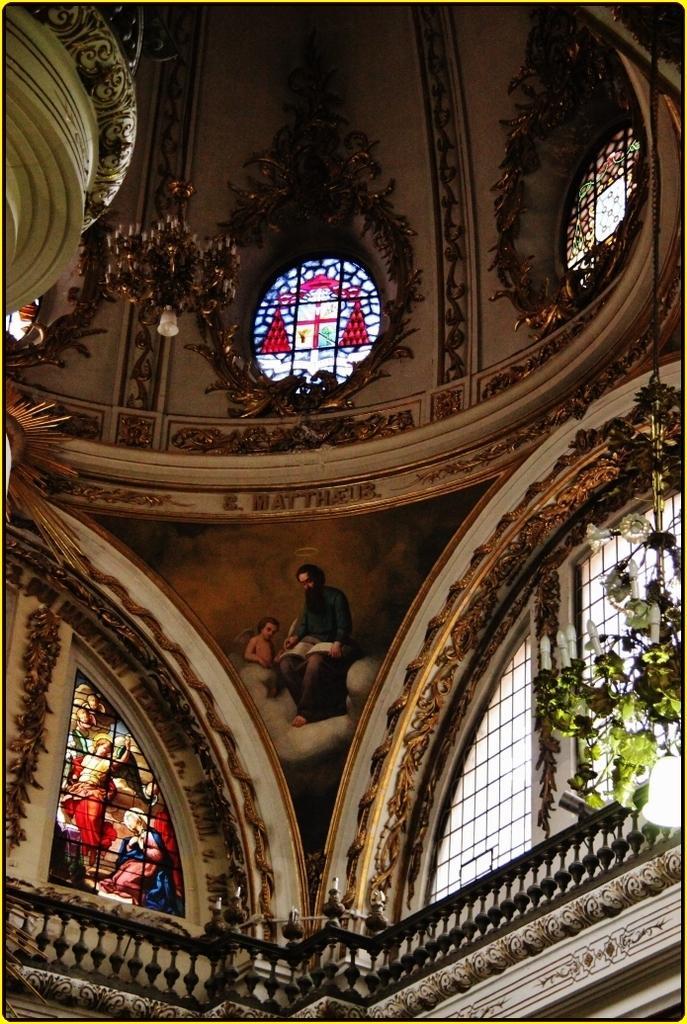Describe this image in one or two sentences. In this image in the center there are windows. On the right side there are leaves on the top there is a chandelier hanging and on the windows there are images of the persons. 